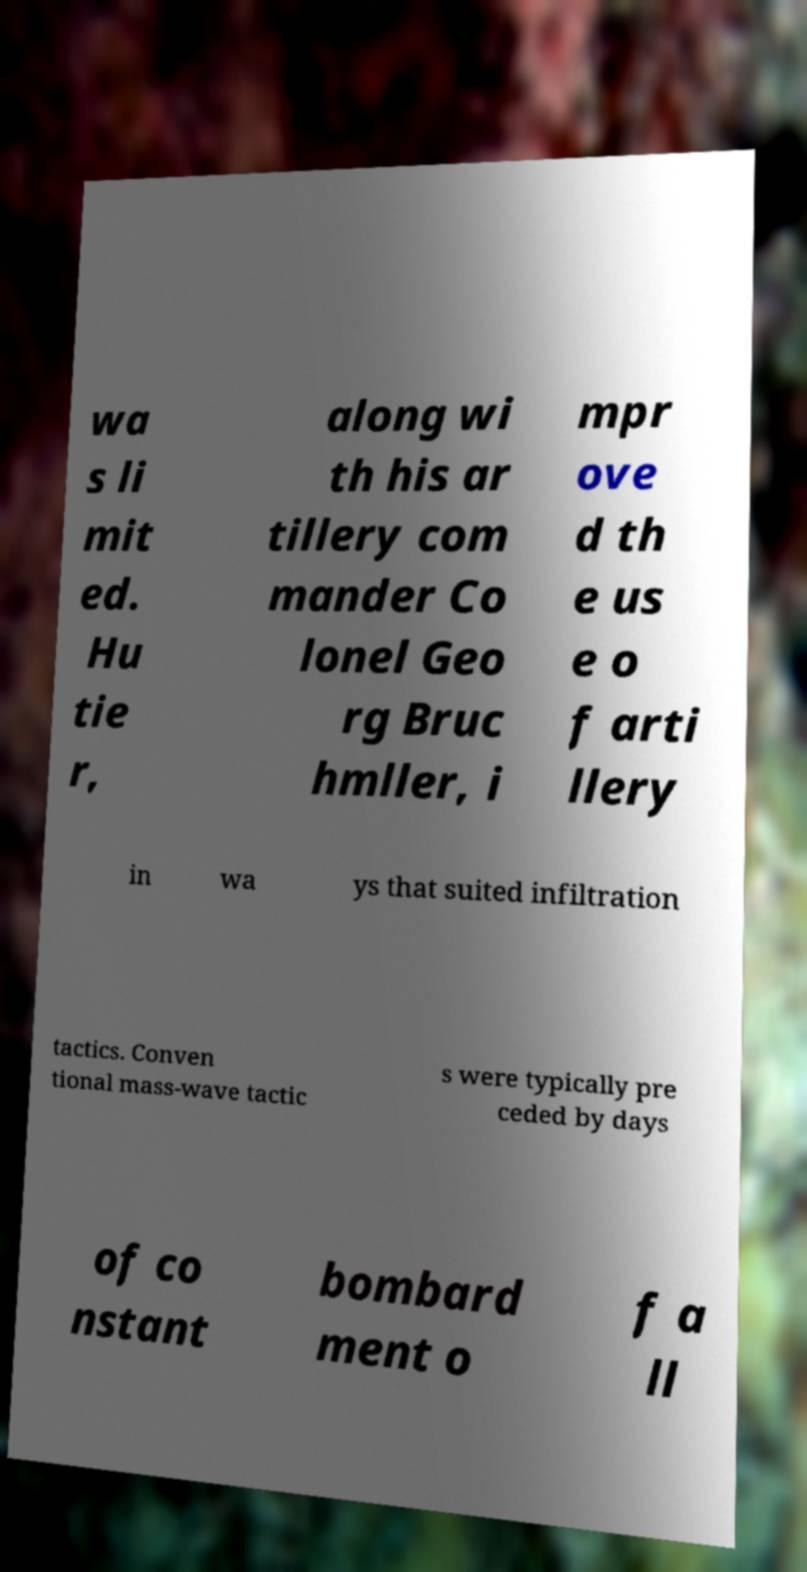Could you assist in decoding the text presented in this image and type it out clearly? wa s li mit ed. Hu tie r, along wi th his ar tillery com mander Co lonel Geo rg Bruc hmller, i mpr ove d th e us e o f arti llery in wa ys that suited infiltration tactics. Conven tional mass-wave tactic s were typically pre ceded by days of co nstant bombard ment o f a ll 